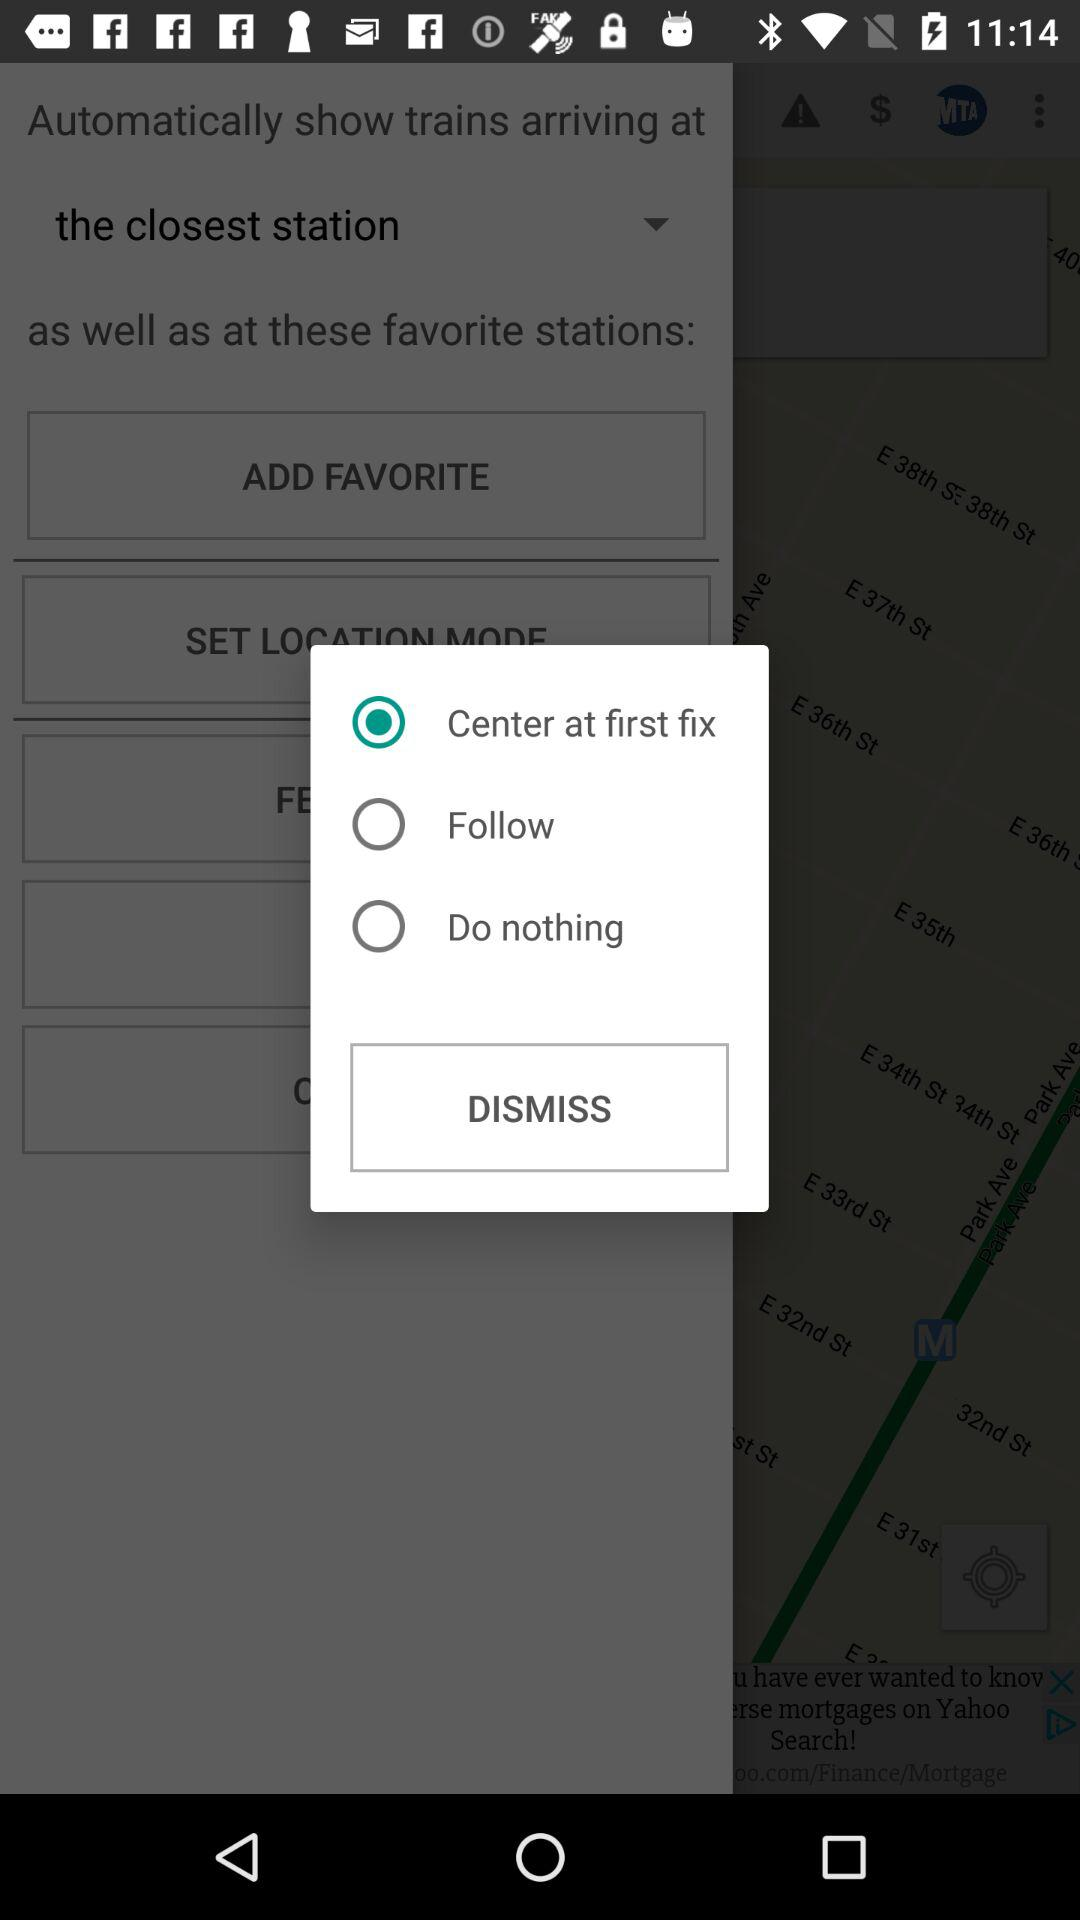What is the status of "Follow"? The status is "off". 